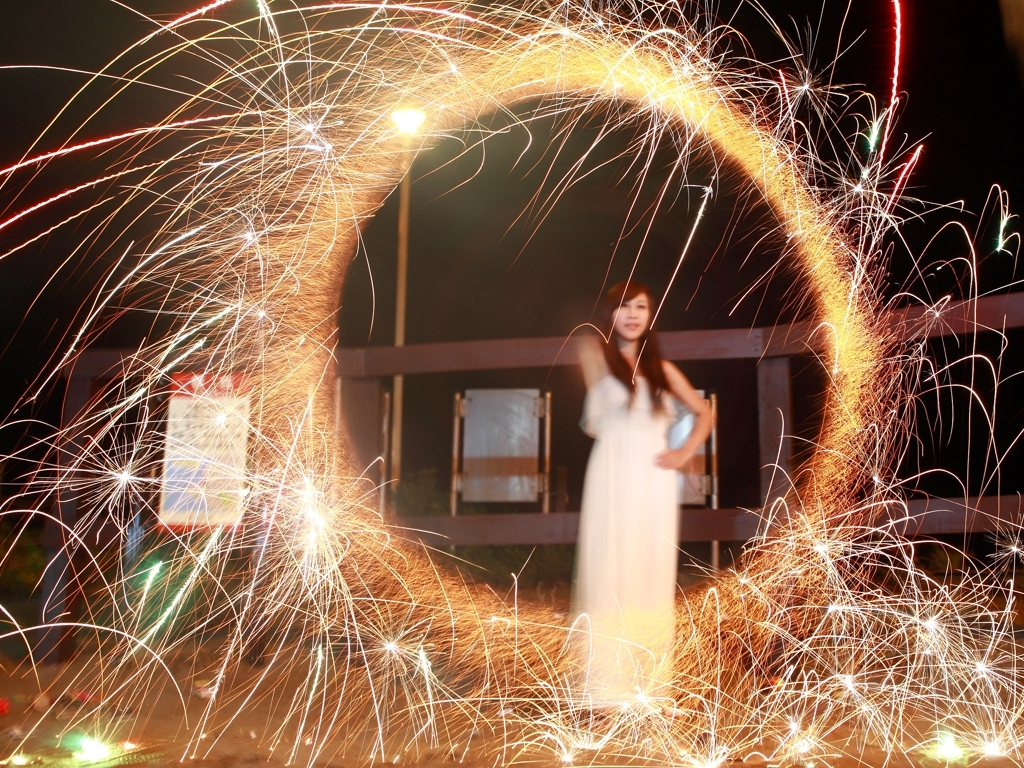What do you think is happening in this image? It appears to be a celebration or an event where people are using sparklers or some kind of pyrotechnic device to create light streaks. The person in the image seems to be part of the festivities, passively observing or posing for the photo amidst an animated display of light and color. 